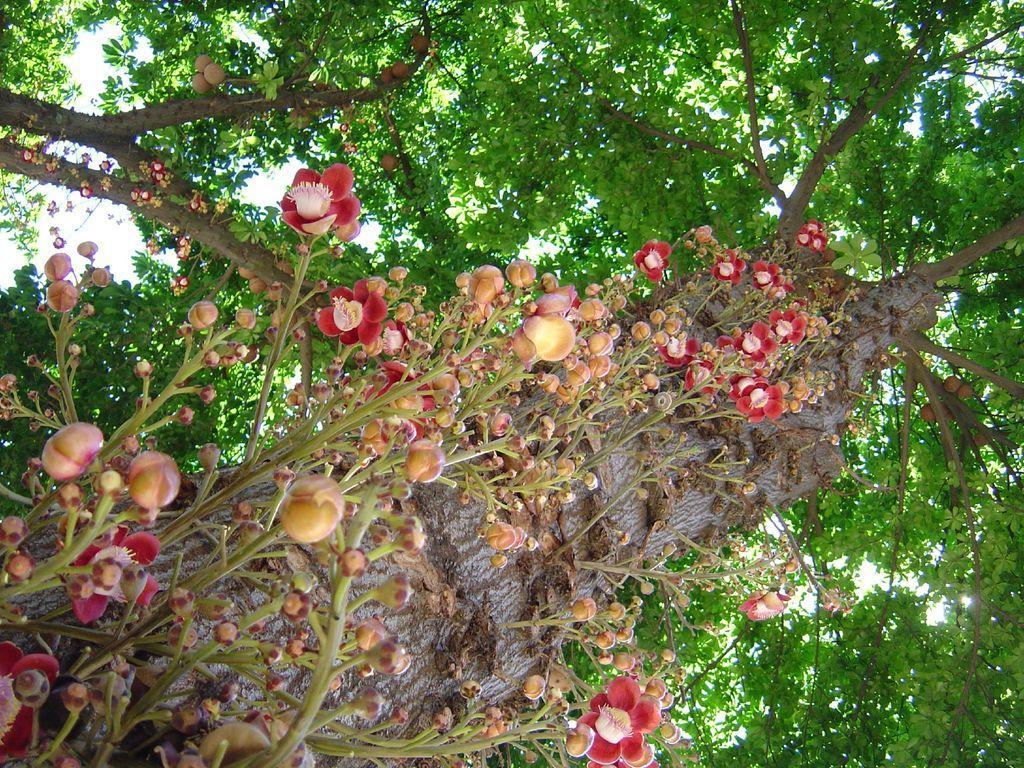Please provide a concise description of this image. In the picture I can see flower plants and trees. In the background I can see the sky. 